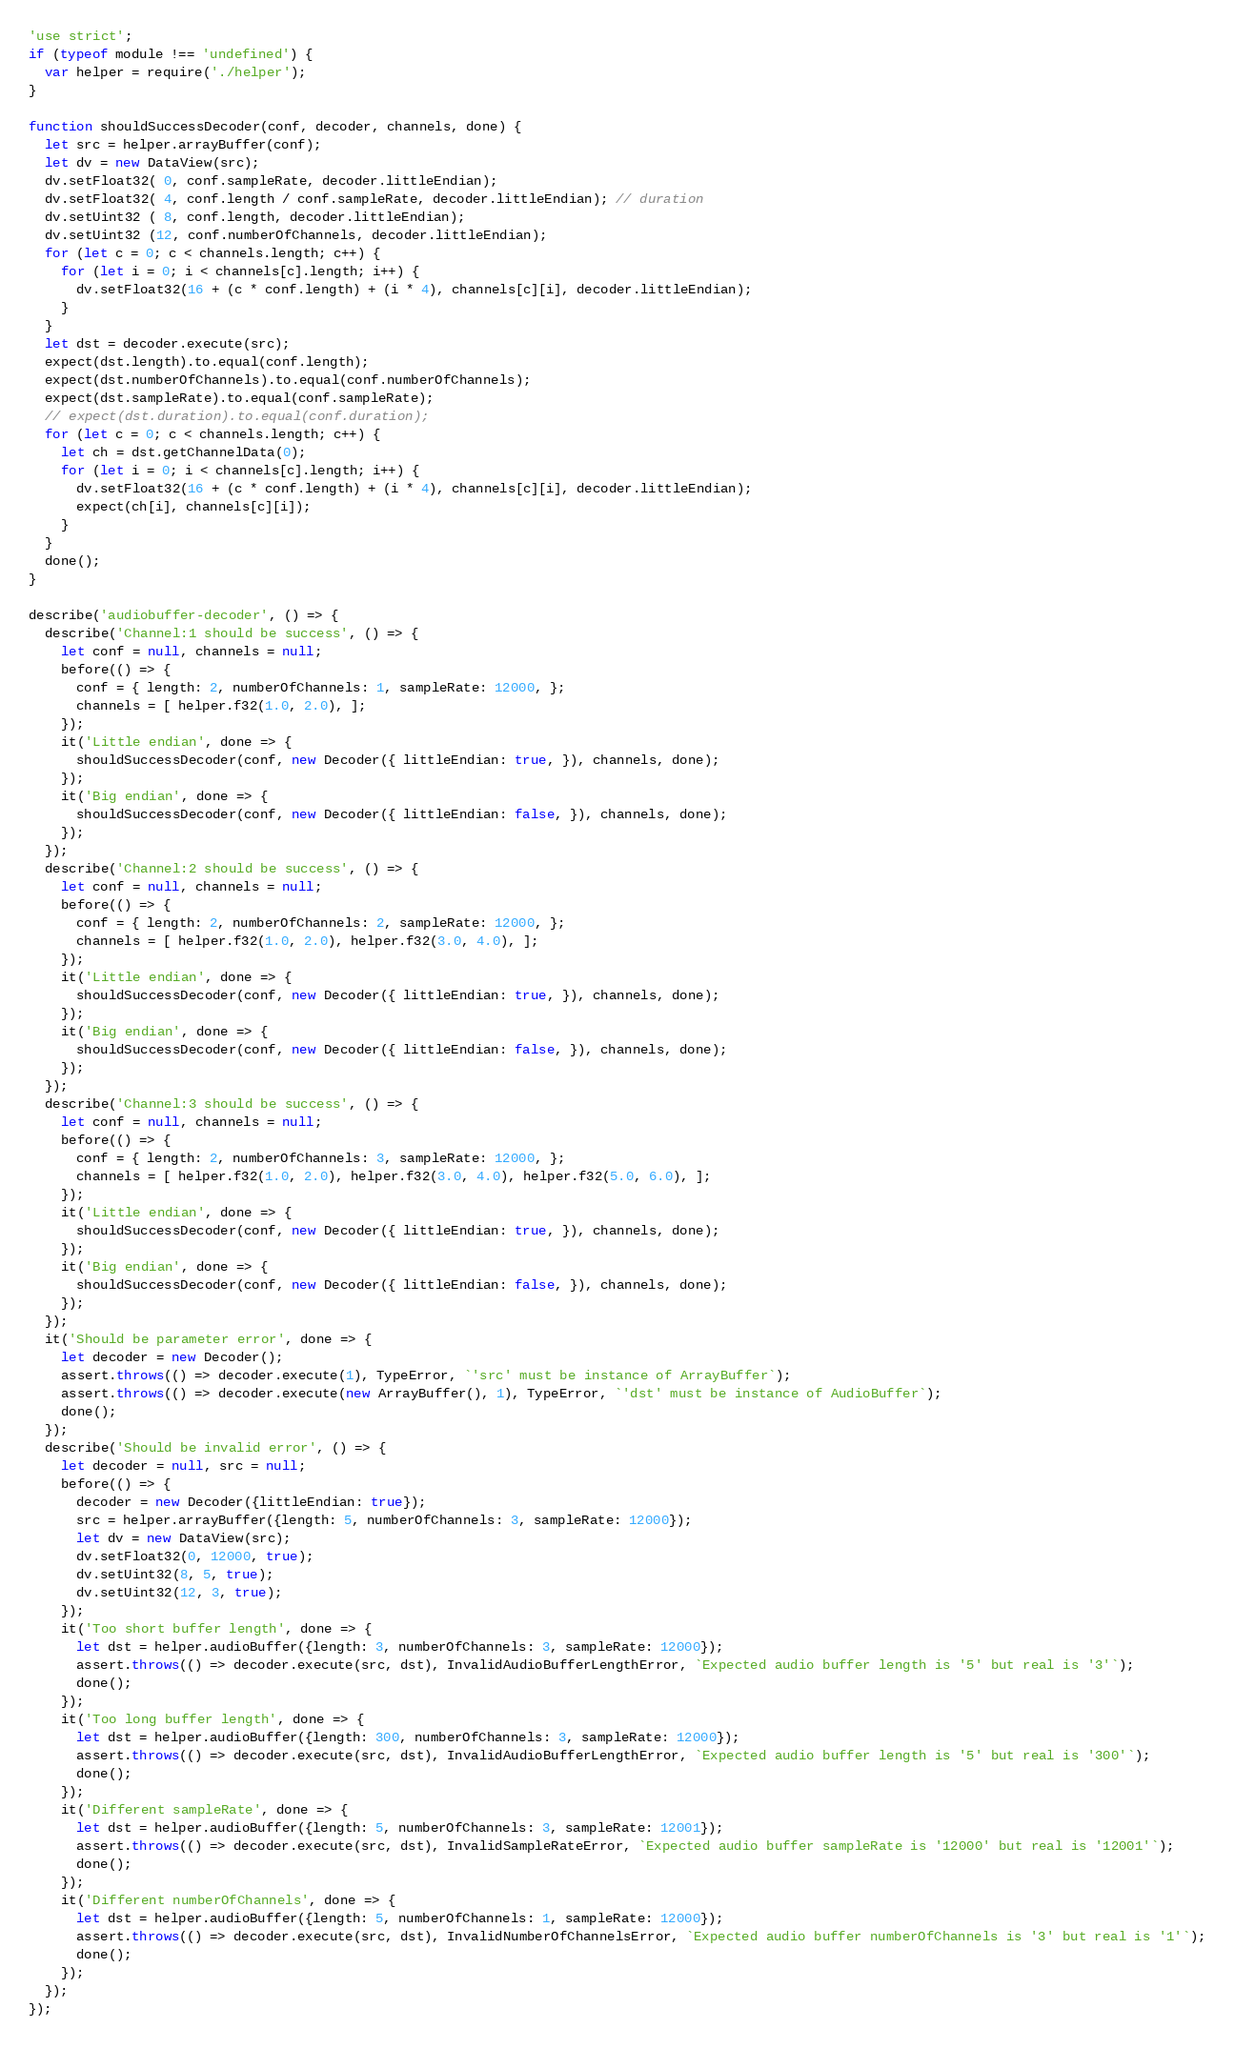Convert code to text. <code><loc_0><loc_0><loc_500><loc_500><_JavaScript_>'use strict';
if (typeof module !== 'undefined') {
  var helper = require('./helper');
}

function shouldSuccessDecoder(conf, decoder, channels, done) {
  let src = helper.arrayBuffer(conf);
  let dv = new DataView(src);
  dv.setFloat32( 0, conf.sampleRate, decoder.littleEndian);
  dv.setFloat32( 4, conf.length / conf.sampleRate, decoder.littleEndian); // duration
  dv.setUint32 ( 8, conf.length, decoder.littleEndian);
  dv.setUint32 (12, conf.numberOfChannels, decoder.littleEndian);
  for (let c = 0; c < channels.length; c++) {
    for (let i = 0; i < channels[c].length; i++) {
      dv.setFloat32(16 + (c * conf.length) + (i * 4), channels[c][i], decoder.littleEndian);
    }
  }
  let dst = decoder.execute(src);
  expect(dst.length).to.equal(conf.length);
  expect(dst.numberOfChannels).to.equal(conf.numberOfChannels);
  expect(dst.sampleRate).to.equal(conf.sampleRate);
  // expect(dst.duration).to.equal(conf.duration);
  for (let c = 0; c < channels.length; c++) {
    let ch = dst.getChannelData(0);
    for (let i = 0; i < channels[c].length; i++) {
      dv.setFloat32(16 + (c * conf.length) + (i * 4), channels[c][i], decoder.littleEndian);
      expect(ch[i], channels[c][i]);
    }
  }
  done();
}

describe('audiobuffer-decoder', () => {
  describe('Channel:1 should be success', () => {
    let conf = null, channels = null;
    before(() => {
      conf = { length: 2, numberOfChannels: 1, sampleRate: 12000, };
      channels = [ helper.f32(1.0, 2.0), ];
    });
    it('Little endian', done => {
      shouldSuccessDecoder(conf, new Decoder({ littleEndian: true, }), channels, done);
    });
    it('Big endian', done => {
      shouldSuccessDecoder(conf, new Decoder({ littleEndian: false, }), channels, done);
    });
  });
  describe('Channel:2 should be success', () => {
    let conf = null, channels = null;
    before(() => {
      conf = { length: 2, numberOfChannels: 2, sampleRate: 12000, };
      channels = [ helper.f32(1.0, 2.0), helper.f32(3.0, 4.0), ];
    });
    it('Little endian', done => {
      shouldSuccessDecoder(conf, new Decoder({ littleEndian: true, }), channels, done);
    });
    it('Big endian', done => {
      shouldSuccessDecoder(conf, new Decoder({ littleEndian: false, }), channels, done);
    });
  });
  describe('Channel:3 should be success', () => {
    let conf = null, channels = null;
    before(() => {
      conf = { length: 2, numberOfChannels: 3, sampleRate: 12000, };
      channels = [ helper.f32(1.0, 2.0), helper.f32(3.0, 4.0), helper.f32(5.0, 6.0), ];
    });
    it('Little endian', done => {
      shouldSuccessDecoder(conf, new Decoder({ littleEndian: true, }), channels, done);
    });
    it('Big endian', done => {
      shouldSuccessDecoder(conf, new Decoder({ littleEndian: false, }), channels, done);
    });
  });
  it('Should be parameter error', done => {
    let decoder = new Decoder();
    assert.throws(() => decoder.execute(1), TypeError, `'src' must be instance of ArrayBuffer`);
    assert.throws(() => decoder.execute(new ArrayBuffer(), 1), TypeError, `'dst' must be instance of AudioBuffer`);
    done();
  });
  describe('Should be invalid error', () => {
    let decoder = null, src = null;
    before(() => {
      decoder = new Decoder({littleEndian: true});
      src = helper.arrayBuffer({length: 5, numberOfChannels: 3, sampleRate: 12000});
      let dv = new DataView(src);
      dv.setFloat32(0, 12000, true);
      dv.setUint32(8, 5, true);
      dv.setUint32(12, 3, true);
    });
    it('Too short buffer length', done => {
      let dst = helper.audioBuffer({length: 3, numberOfChannels: 3, sampleRate: 12000});
      assert.throws(() => decoder.execute(src, dst), InvalidAudioBufferLengthError, `Expected audio buffer length is '5' but real is '3'`);
      done();
    });
    it('Too long buffer length', done => {
      let dst = helper.audioBuffer({length: 300, numberOfChannels: 3, sampleRate: 12000});
      assert.throws(() => decoder.execute(src, dst), InvalidAudioBufferLengthError, `Expected audio buffer length is '5' but real is '300'`);
      done();
    });
    it('Different sampleRate', done => {
      let dst = helper.audioBuffer({length: 5, numberOfChannels: 3, sampleRate: 12001});
      assert.throws(() => decoder.execute(src, dst), InvalidSampleRateError, `Expected audio buffer sampleRate is '12000' but real is '12001'`);
      done();
    });
    it('Different numberOfChannels', done => {
      let dst = helper.audioBuffer({length: 5, numberOfChannels: 1, sampleRate: 12000});
      assert.throws(() => decoder.execute(src, dst), InvalidNumberOfChannelsError, `Expected audio buffer numberOfChannels is '3' but real is '1'`);
      done();
    });
  });
});</code> 